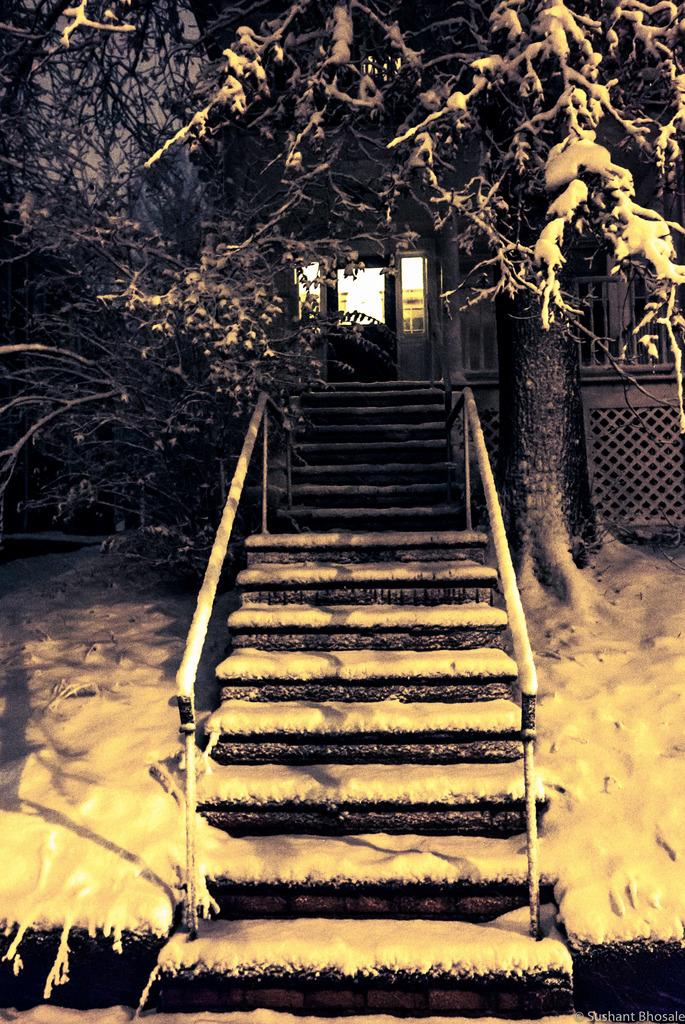What type of structure can be seen in the background of the image? There is a building in the background of the image. What is the condition of the staircases in the image? The staircases have snow in the image. What type of vegetation is present in the image? There are trees in the image. How many toes are visible on the trees in the image? Trees do not have toes, so none are visible in the image. Is it raining in the image? There is no mention of rain in the provided facts, so we cannot determine if it is raining in the image. 